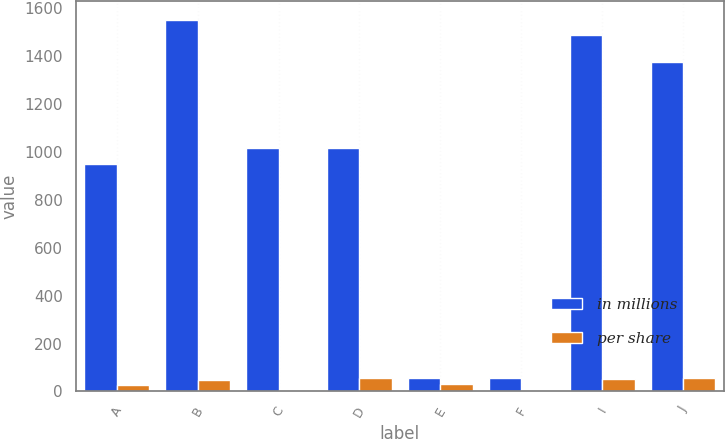Convert chart. <chart><loc_0><loc_0><loc_500><loc_500><stacked_bar_chart><ecel><fcel>A<fcel>B<fcel>C<fcel>D<fcel>E<fcel>F<fcel>I<fcel>J<nl><fcel>in millions<fcel>950.51<fcel>1550<fcel>1013.9<fcel>1013.9<fcel>55<fcel>55<fcel>1487.52<fcel>1375<nl><fcel>per share<fcel>29<fcel>50<fcel>8<fcel>55<fcel>31<fcel>6<fcel>51<fcel>55<nl></chart> 